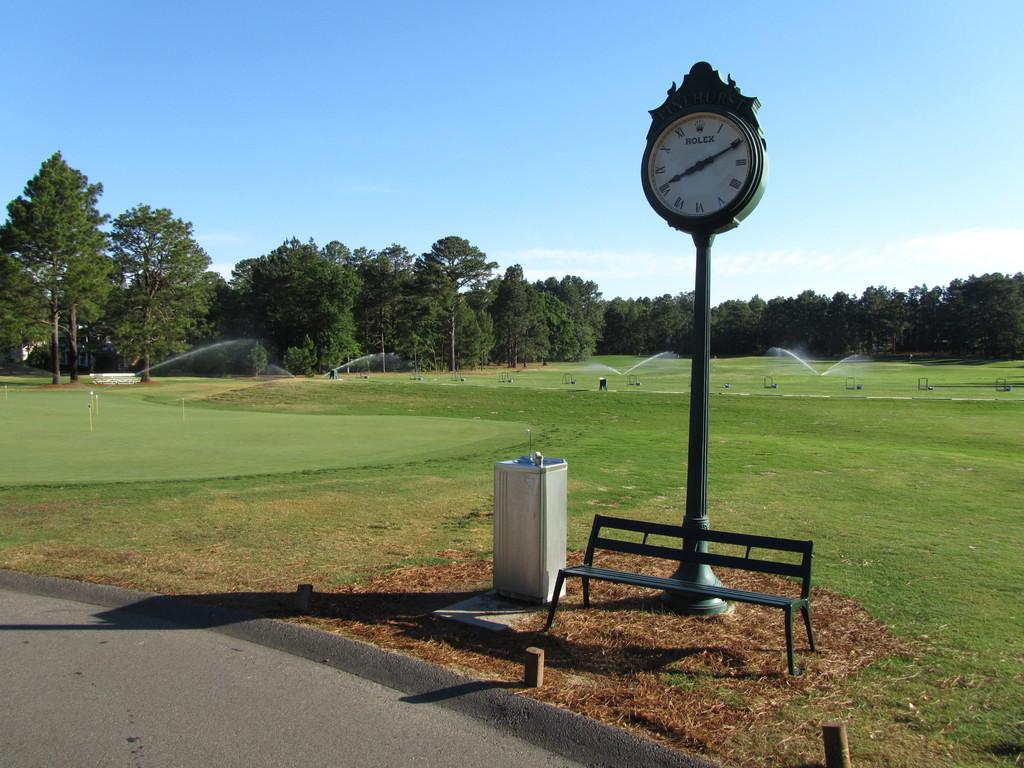What time is it according to the clock?
Provide a succinct answer. 8:10. What is the brand of that clock?
Provide a short and direct response. Rolex. 